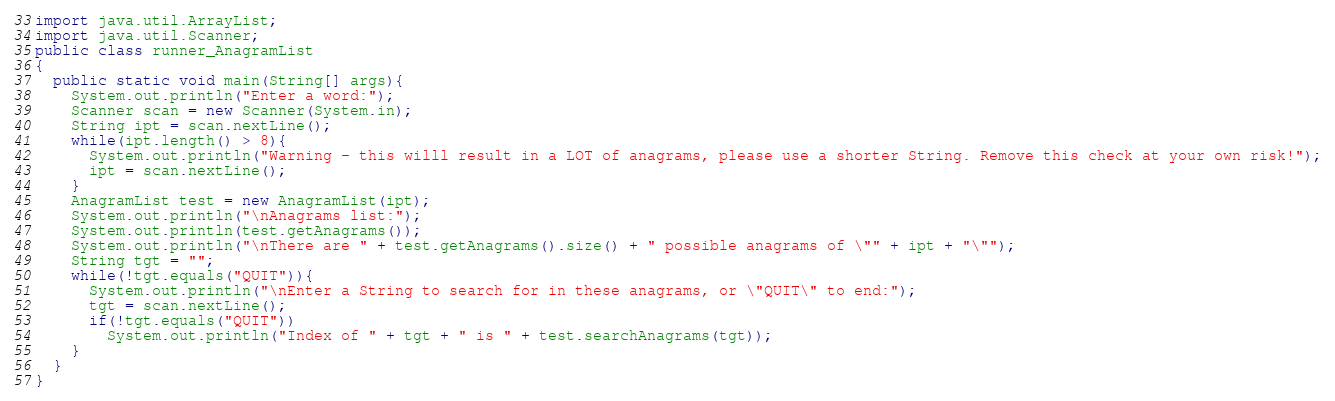<code> <loc_0><loc_0><loc_500><loc_500><_Java_>import java.util.ArrayList;
import java.util.Scanner;
public class runner_AnagramList
{
  public static void main(String[] args){
    System.out.println("Enter a word:");
    Scanner scan = new Scanner(System.in);
    String ipt = scan.nextLine();
    while(ipt.length() > 8){
      System.out.println("Warning - this willl result in a LOT of anagrams, please use a shorter String. Remove this check at your own risk!");
      ipt = scan.nextLine();
    }
    AnagramList test = new AnagramList(ipt);
    System.out.println("\nAnagrams list:");
    System.out.println(test.getAnagrams());
    System.out.println("\nThere are " + test.getAnagrams().size() + " possible anagrams of \"" + ipt + "\"");
    String tgt = "";
    while(!tgt.equals("QUIT")){
      System.out.println("\nEnter a String to search for in these anagrams, or \"QUIT\" to end:");
      tgt = scan.nextLine();
      if(!tgt.equals("QUIT"))
        System.out.println("Index of " + tgt + " is " + test.searchAnagrams(tgt));
    }
  }
}
</code> 